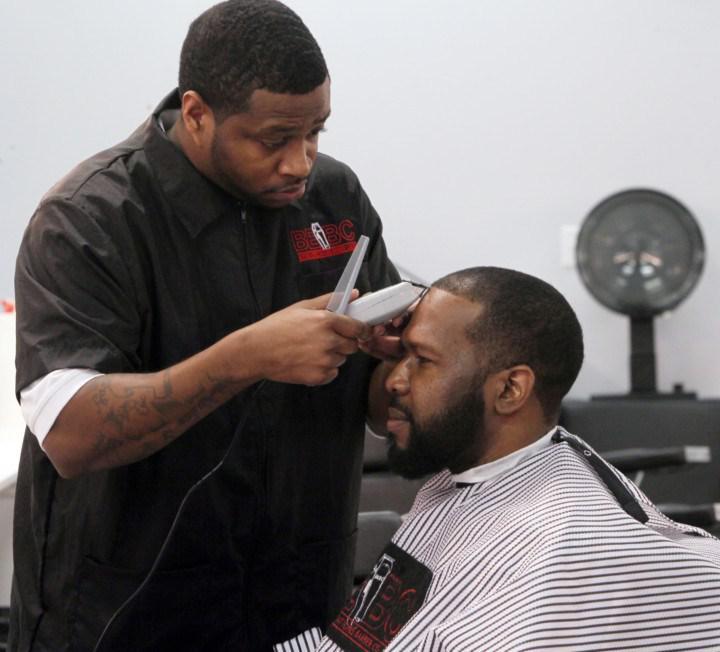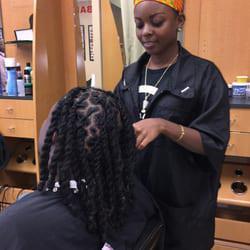The first image is the image on the left, the second image is the image on the right. Assess this claim about the two images: "The left and right image contains the same number of people in the barber shop with at least one being a woman.". Correct or not? Answer yes or no. Yes. 